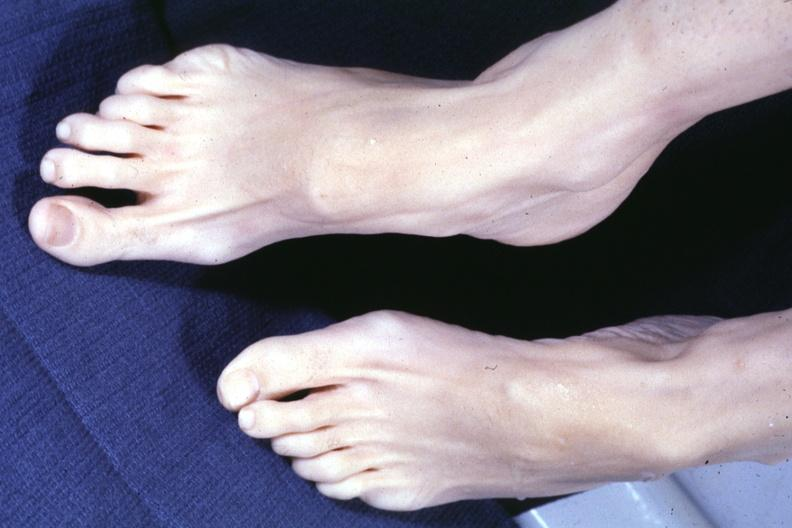re extremities present?
Answer the question using a single word or phrase. Yes 